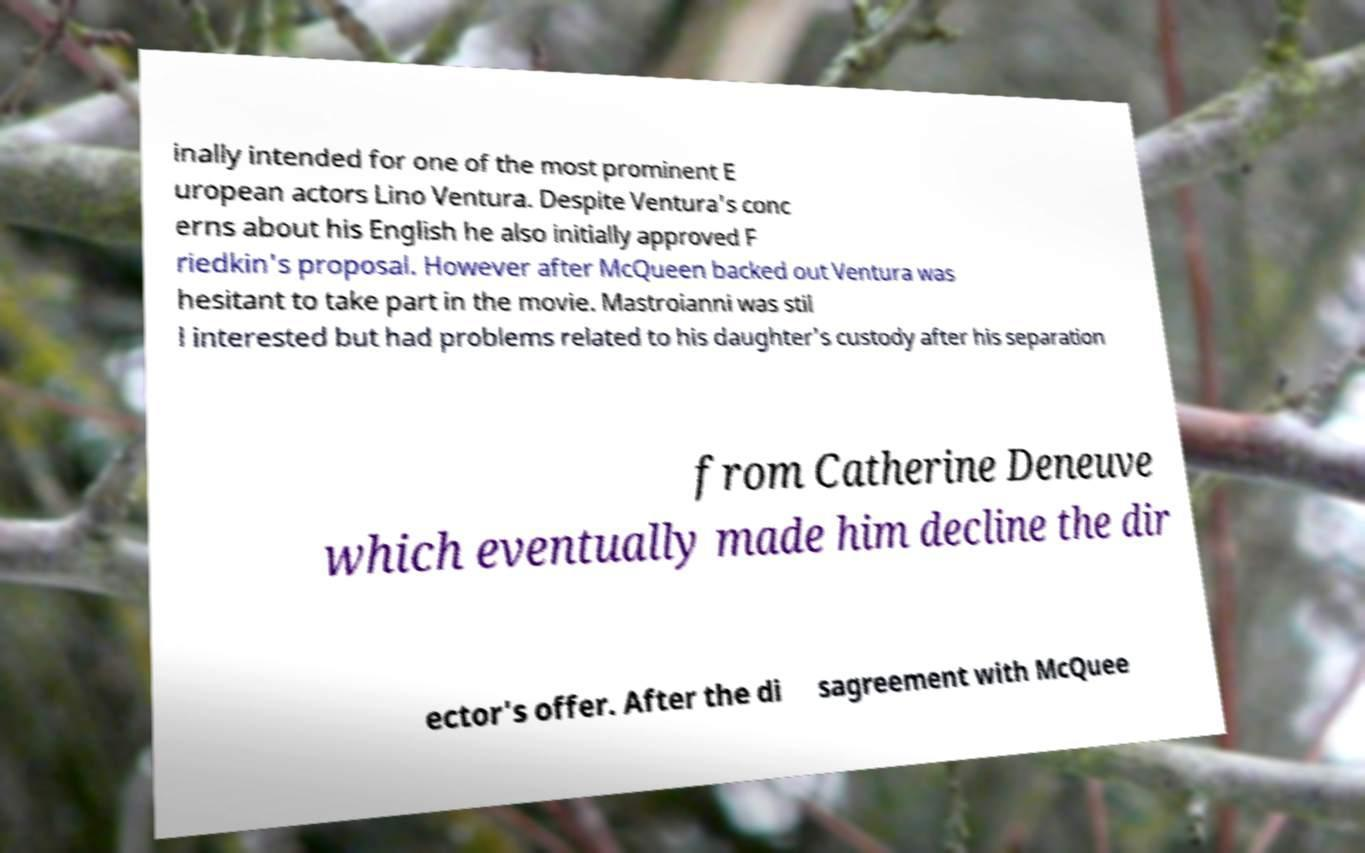Please read and relay the text visible in this image. What does it say? inally intended for one of the most prominent E uropean actors Lino Ventura. Despite Ventura's conc erns about his English he also initially approved F riedkin's proposal. However after McQueen backed out Ventura was hesitant to take part in the movie. Mastroianni was stil l interested but had problems related to his daughter's custody after his separation from Catherine Deneuve which eventually made him decline the dir ector's offer. After the di sagreement with McQuee 